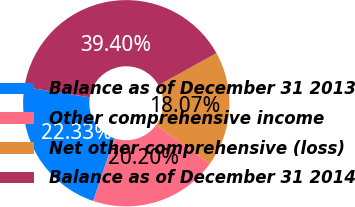Convert chart to OTSL. <chart><loc_0><loc_0><loc_500><loc_500><pie_chart><fcel>Balance as of December 31 2013<fcel>Other comprehensive income<fcel>Net other comprehensive (loss)<fcel>Balance as of December 31 2014<nl><fcel>22.33%<fcel>20.2%<fcel>18.07%<fcel>39.4%<nl></chart> 